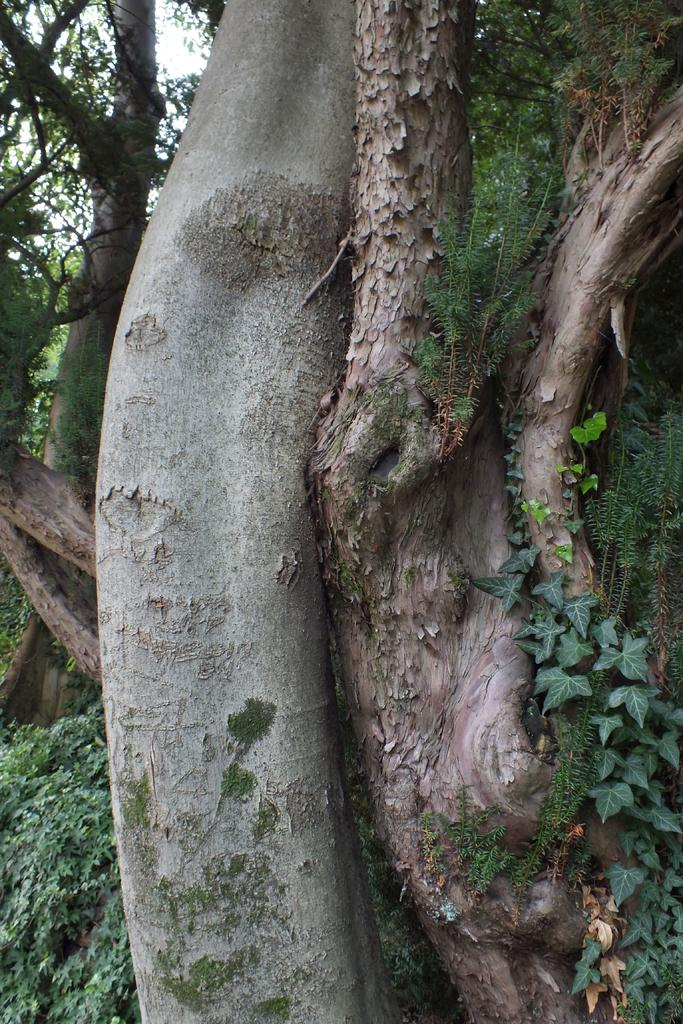What part of a tree can be seen in the image? The bark of a tree is visible in the image. What other types of vegetation are present in the image? There are plants in the image. Can you describe the main tree in the image? There is a tree in the image. What is visible in the background of the image? The sky is visible in the image. How would you describe the weather based on the appearance of the sky? The sky appears cloudy in the image. What type of cracker is being used to decorate the tree in the image? There is no cracker present in the image; it features a tree with visible bark and plants. Is there a scarf wrapped around the tree in the image? No, there is no scarf present in the image. 